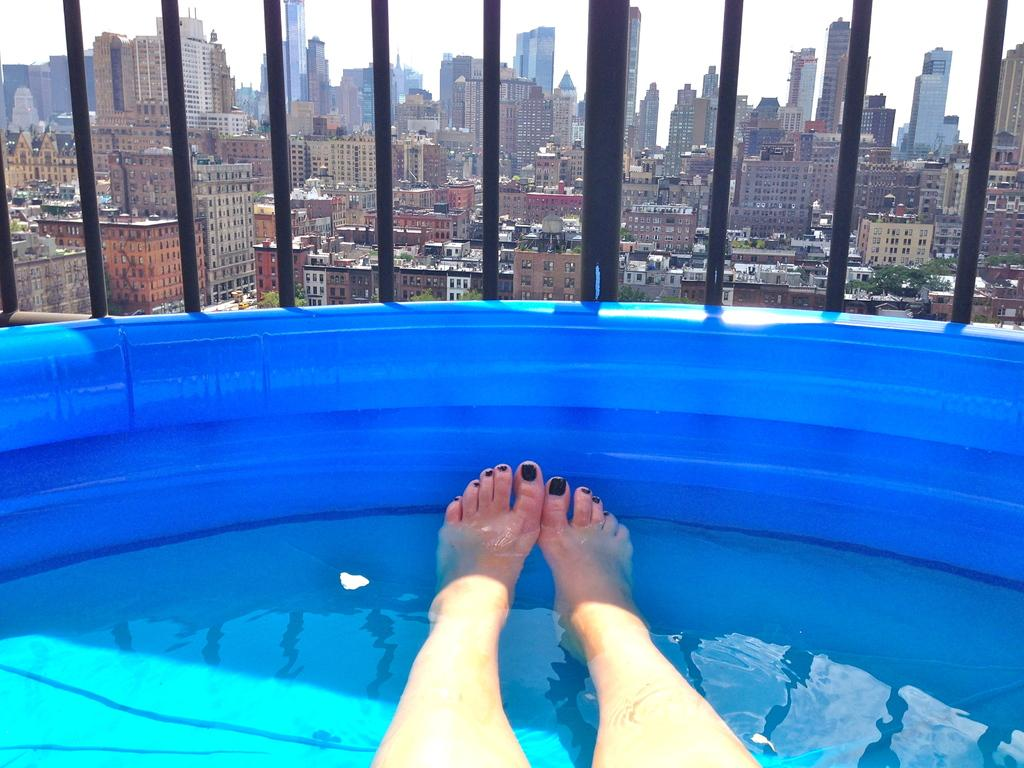What part of a person can be seen in the water in the image? There are person's legs in the water in the image. What type of structures are visible in the image? There are buildings in the image. What type of fencing is present in the image? There are iron grills in the image. What type of vegetation is visible in the image? There are trees in the image. What part of the natural environment is visible in the image? The sky is visible in the image. What word is the yak saying in the image? There is no yak present in the image, so it is not possible to determine what word it might be saying. 